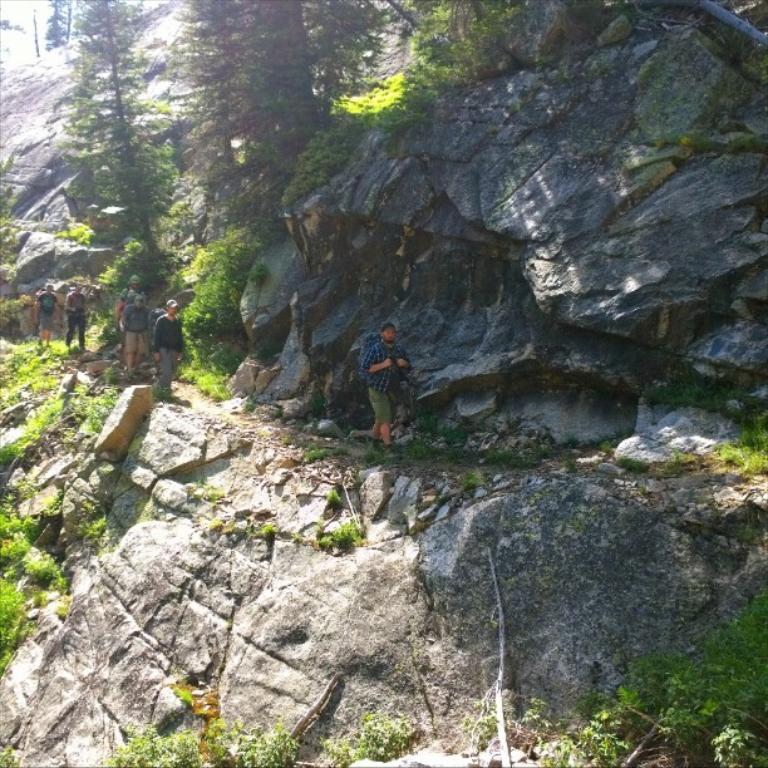Please provide a concise description of this image. In this image, there are a few people. We can see some rock hills and grass. We can also see some plants and trees. 